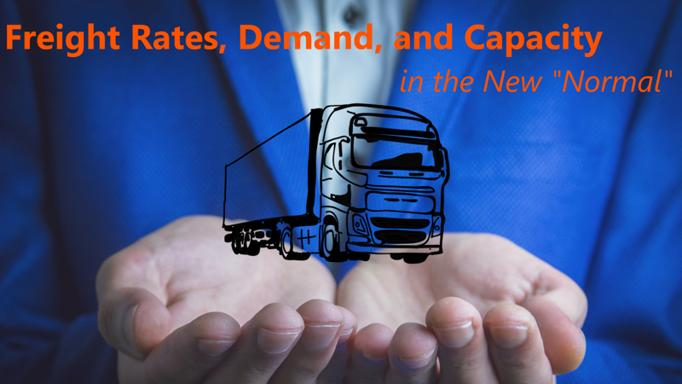Why might someone hold a truck in their hands in this context? The imagery of a man holding a truck symbolizes the direct control and strategic management companies must exert over their operations concerning freight rates, demand, and capacity. It emphasizes the need for hands-on leadership and agile responses to market changes to ensure the smooth functioning and profitability of trucking operations in new economic conditions. 